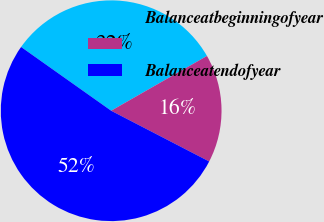Convert chart to OTSL. <chart><loc_0><loc_0><loc_500><loc_500><pie_chart><fcel>Balanceatbeginningofyear<fcel>Unnamed: 1<fcel>Balanceatendofyear<nl><fcel>31.93%<fcel>15.87%<fcel>52.21%<nl></chart> 